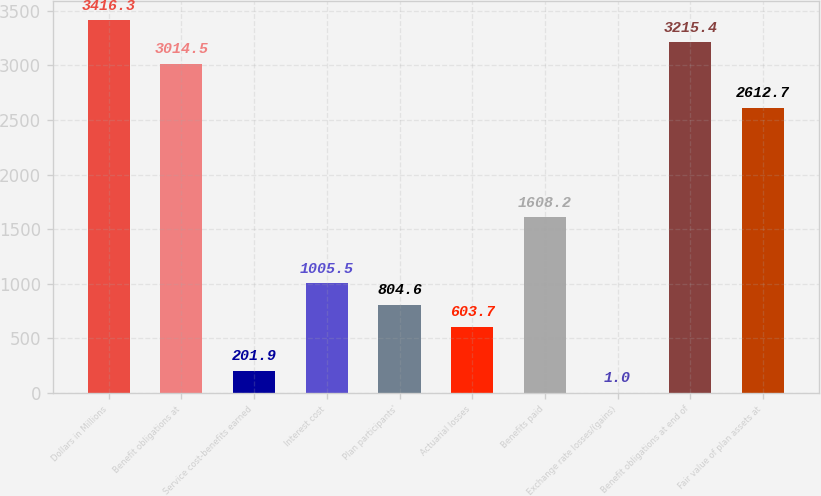<chart> <loc_0><loc_0><loc_500><loc_500><bar_chart><fcel>Dollars in Millions<fcel>Benefit obligations at<fcel>Service cost-benefits earned<fcel>Interest cost<fcel>Plan participants'<fcel>Actuarial losses<fcel>Benefits paid<fcel>Exchange rate losses/(gains)<fcel>Benefit obligations at end of<fcel>Fair value of plan assets at<nl><fcel>3416.3<fcel>3014.5<fcel>201.9<fcel>1005.5<fcel>804.6<fcel>603.7<fcel>1608.2<fcel>1<fcel>3215.4<fcel>2612.7<nl></chart> 